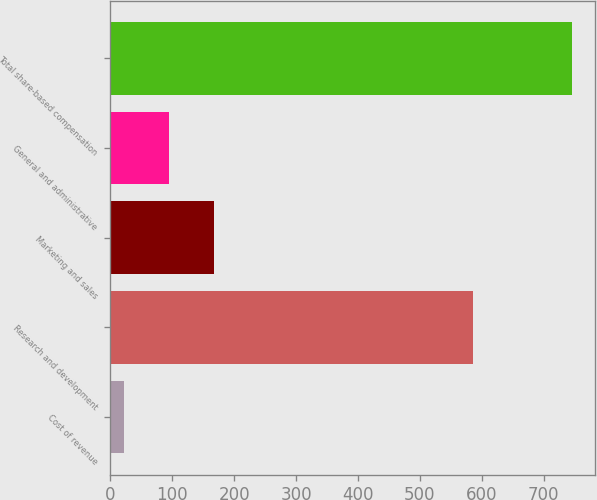Convert chart. <chart><loc_0><loc_0><loc_500><loc_500><bar_chart><fcel>Cost of revenue<fcel>Research and development<fcel>Marketing and sales<fcel>General and administrative<fcel>Total share-based compensation<nl><fcel>22<fcel>586<fcel>166.8<fcel>94.4<fcel>746<nl></chart> 